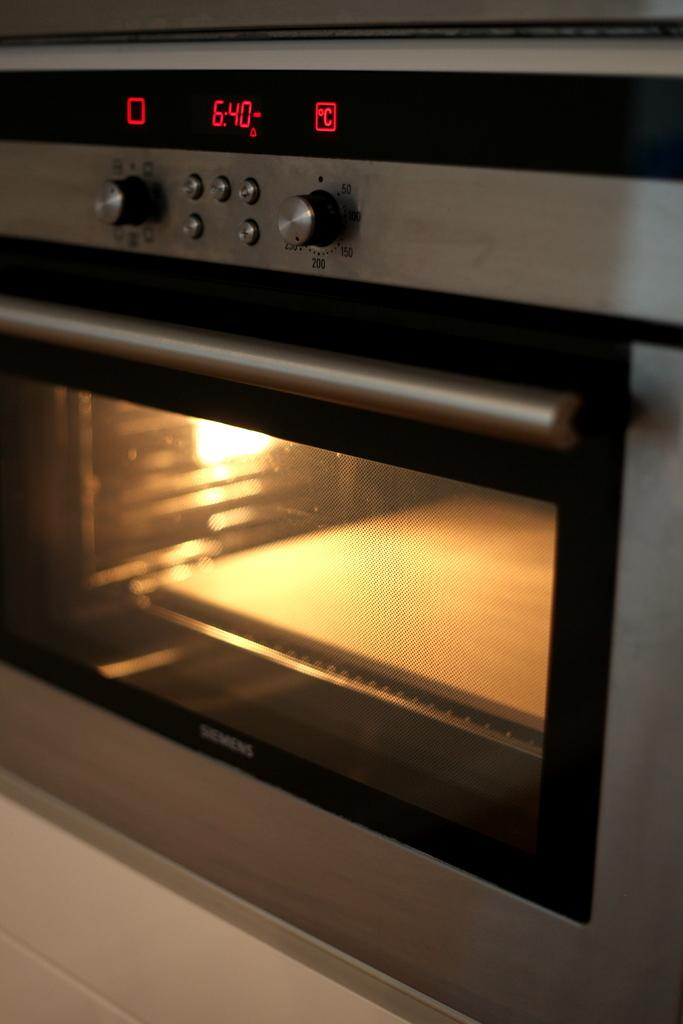What appliance is visible in the image? There is a microwave oven in the image. Where is the microwave oven located? The microwave oven is on a platform. Is there a volleyball game happening on the ground in the image? There is no volleyball game or ground present in the image; it only features a microwave oven on a platform. 